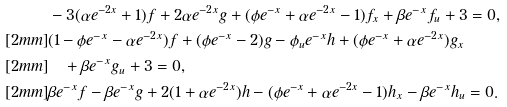<formula> <loc_0><loc_0><loc_500><loc_500>& - 3 ( \alpha e ^ { - 2 x } + 1 ) f + 2 \alpha e ^ { - 2 x } g + ( \phi e ^ { - x } + \alpha e ^ { - 2 x } - 1 ) f _ { x } + \beta e ^ { - x } f _ { u } + 3 = 0 , \\ [ 2 m m ] & ( 1 - \phi e ^ { - x } - \alpha e ^ { - 2 x } ) f + ( \phi e ^ { - x } - 2 ) g - \phi _ { u } e ^ { - x } h + ( \phi e ^ { - x } + \alpha e ^ { - 2 x } ) g _ { x } \\ [ 2 m m ] & \quad + \beta e ^ { - x } g _ { u } + 3 = 0 , \\ [ 2 m m ] & \beta e ^ { - x } f - \beta e ^ { - x } g + 2 ( 1 + \alpha e ^ { - 2 x } ) h - ( \phi e ^ { - x } + \alpha e ^ { - 2 x } - 1 ) h _ { x } - \beta e ^ { - x } h _ { u } = 0 .</formula> 